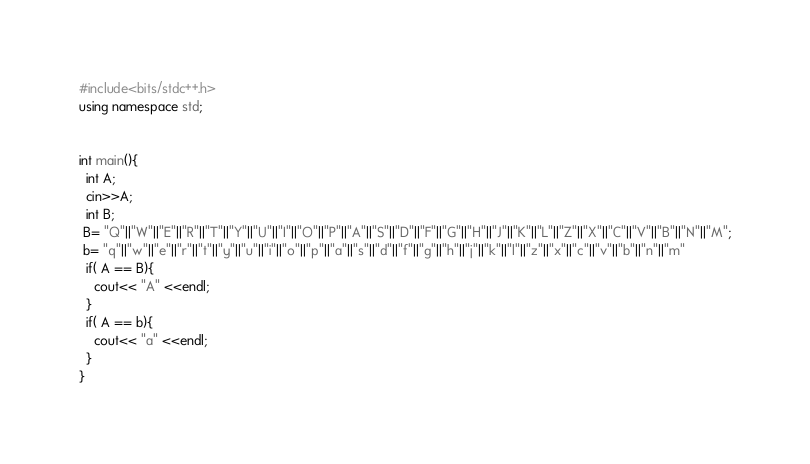<code> <loc_0><loc_0><loc_500><loc_500><_C++_>#include<bits/stdc++.h>
using namespace std;


int main(){
  int A;
  cin>>A;
  int B;
 B= "Q"||"W"||"E"||"R"||"T"||"Y"||"U"||"I"||"O"||"P"||"A"||"S"||"D"||"F"||"G"||"H"||"J"||"K"||"L"||"Z"||"X"||"C"||"V"||"B"||"N"||"M";
 b= "q"||"w"||"e"||"r"||"t"||"y"||"u"||"i"||"o"||"p"||"a"||"s"||"d"||"f"||"g"||"h"||"j"||"k"||"l"||"z"||"x"||"c"||"v"||"b"||"n"||"m"
  if( A == B){
    cout<< "A" <<endl;
  }
  if( A == b){
    cout<< "a" <<endl;
  }
}</code> 